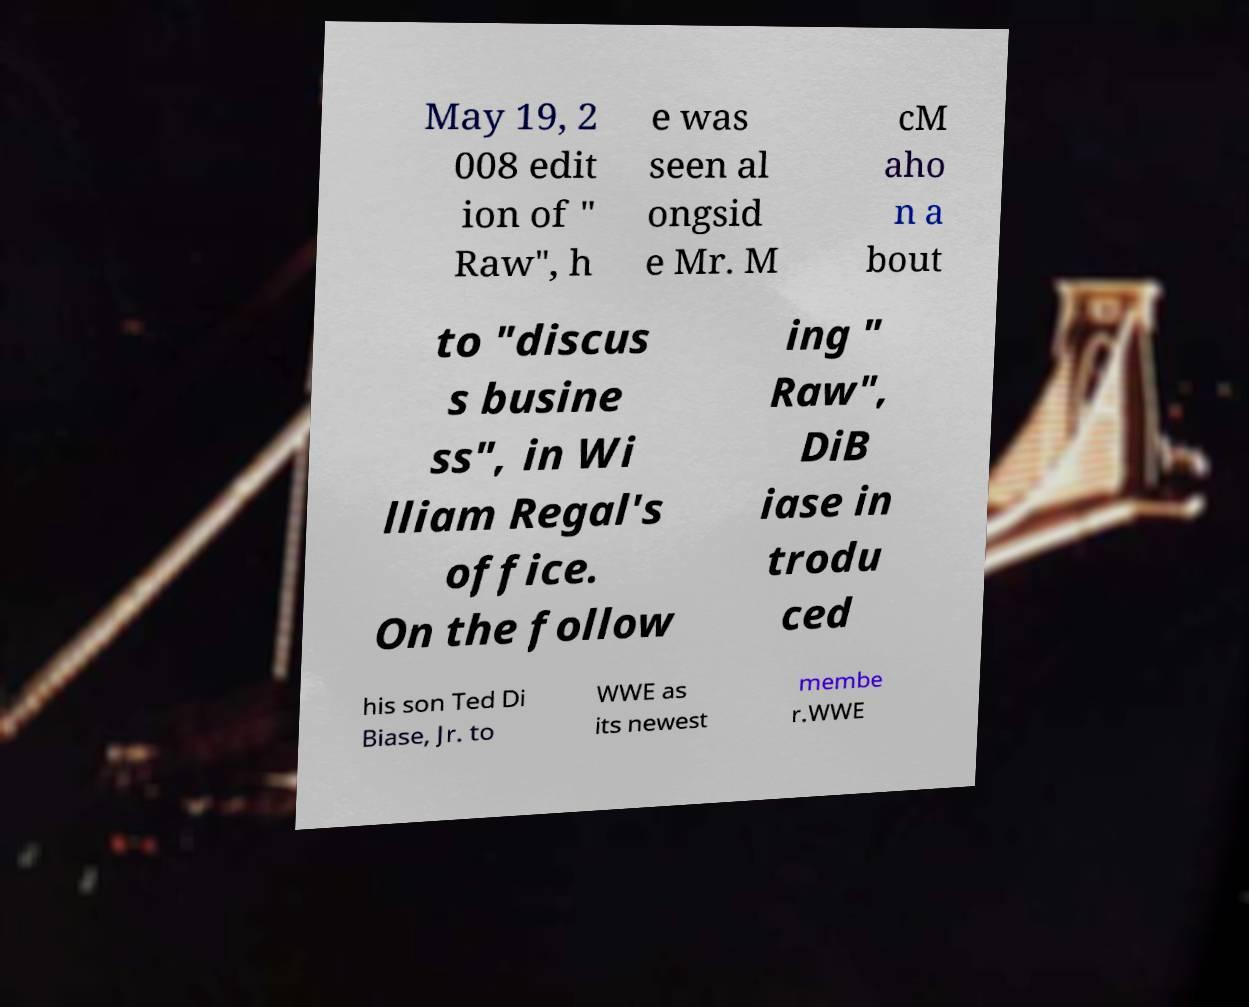Please identify and transcribe the text found in this image. May 19, 2 008 edit ion of " Raw", h e was seen al ongsid e Mr. M cM aho n a bout to "discus s busine ss", in Wi lliam Regal's office. On the follow ing " Raw", DiB iase in trodu ced his son Ted Di Biase, Jr. to WWE as its newest membe r.WWE 